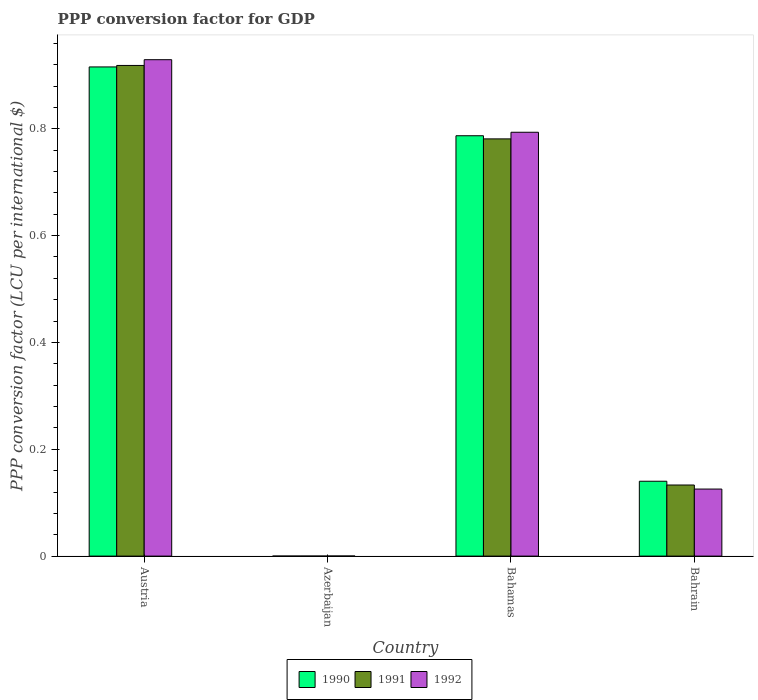How many different coloured bars are there?
Give a very brief answer. 3. How many bars are there on the 3rd tick from the left?
Offer a terse response. 3. What is the label of the 2nd group of bars from the left?
Keep it short and to the point. Azerbaijan. In how many cases, is the number of bars for a given country not equal to the number of legend labels?
Offer a terse response. 0. What is the PPP conversion factor for GDP in 1991 in Azerbaijan?
Give a very brief answer. 1.32217766768327e-5. Across all countries, what is the maximum PPP conversion factor for GDP in 1992?
Ensure brevity in your answer.  0.93. Across all countries, what is the minimum PPP conversion factor for GDP in 1990?
Offer a very short reply. 7.443149847604138e-6. In which country was the PPP conversion factor for GDP in 1991 maximum?
Offer a very short reply. Austria. In which country was the PPP conversion factor for GDP in 1990 minimum?
Make the answer very short. Azerbaijan. What is the total PPP conversion factor for GDP in 1992 in the graph?
Your response must be concise. 1.85. What is the difference between the PPP conversion factor for GDP in 1992 in Austria and that in Bahrain?
Ensure brevity in your answer.  0.8. What is the difference between the PPP conversion factor for GDP in 1992 in Azerbaijan and the PPP conversion factor for GDP in 1990 in Austria?
Make the answer very short. -0.92. What is the average PPP conversion factor for GDP in 1990 per country?
Keep it short and to the point. 0.46. What is the difference between the PPP conversion factor for GDP of/in 1992 and PPP conversion factor for GDP of/in 1990 in Austria?
Provide a succinct answer. 0.01. In how many countries, is the PPP conversion factor for GDP in 1991 greater than 0.08 LCU?
Your response must be concise. 3. What is the ratio of the PPP conversion factor for GDP in 1992 in Bahamas to that in Bahrain?
Your answer should be very brief. 6.32. Is the PPP conversion factor for GDP in 1991 in Austria less than that in Bahrain?
Your answer should be very brief. No. What is the difference between the highest and the second highest PPP conversion factor for GDP in 1990?
Your response must be concise. 0.13. What is the difference between the highest and the lowest PPP conversion factor for GDP in 1991?
Give a very brief answer. 0.92. Is the sum of the PPP conversion factor for GDP in 1991 in Austria and Bahrain greater than the maximum PPP conversion factor for GDP in 1992 across all countries?
Make the answer very short. Yes. Are all the bars in the graph horizontal?
Your answer should be compact. No. Are the values on the major ticks of Y-axis written in scientific E-notation?
Offer a very short reply. No. Does the graph contain any zero values?
Provide a short and direct response. No. Does the graph contain grids?
Ensure brevity in your answer.  No. How many legend labels are there?
Keep it short and to the point. 3. How are the legend labels stacked?
Your answer should be compact. Horizontal. What is the title of the graph?
Make the answer very short. PPP conversion factor for GDP. Does "2010" appear as one of the legend labels in the graph?
Provide a short and direct response. No. What is the label or title of the X-axis?
Make the answer very short. Country. What is the label or title of the Y-axis?
Give a very brief answer. PPP conversion factor (LCU per international $). What is the PPP conversion factor (LCU per international $) in 1990 in Austria?
Make the answer very short. 0.92. What is the PPP conversion factor (LCU per international $) in 1991 in Austria?
Provide a short and direct response. 0.92. What is the PPP conversion factor (LCU per international $) of 1992 in Austria?
Your answer should be very brief. 0.93. What is the PPP conversion factor (LCU per international $) of 1990 in Azerbaijan?
Provide a succinct answer. 7.443149847604138e-6. What is the PPP conversion factor (LCU per international $) of 1991 in Azerbaijan?
Your response must be concise. 1.32217766768327e-5. What is the PPP conversion factor (LCU per international $) in 1992 in Azerbaijan?
Ensure brevity in your answer.  0. What is the PPP conversion factor (LCU per international $) of 1990 in Bahamas?
Offer a very short reply. 0.79. What is the PPP conversion factor (LCU per international $) in 1991 in Bahamas?
Your answer should be very brief. 0.78. What is the PPP conversion factor (LCU per international $) of 1992 in Bahamas?
Ensure brevity in your answer.  0.79. What is the PPP conversion factor (LCU per international $) of 1990 in Bahrain?
Offer a very short reply. 0.14. What is the PPP conversion factor (LCU per international $) of 1991 in Bahrain?
Offer a very short reply. 0.13. What is the PPP conversion factor (LCU per international $) in 1992 in Bahrain?
Provide a succinct answer. 0.13. Across all countries, what is the maximum PPP conversion factor (LCU per international $) of 1990?
Your response must be concise. 0.92. Across all countries, what is the maximum PPP conversion factor (LCU per international $) in 1991?
Provide a succinct answer. 0.92. Across all countries, what is the maximum PPP conversion factor (LCU per international $) of 1992?
Ensure brevity in your answer.  0.93. Across all countries, what is the minimum PPP conversion factor (LCU per international $) in 1990?
Make the answer very short. 7.443149847604138e-6. Across all countries, what is the minimum PPP conversion factor (LCU per international $) in 1991?
Your answer should be compact. 1.32217766768327e-5. Across all countries, what is the minimum PPP conversion factor (LCU per international $) in 1992?
Ensure brevity in your answer.  0. What is the total PPP conversion factor (LCU per international $) of 1990 in the graph?
Offer a terse response. 1.84. What is the total PPP conversion factor (LCU per international $) of 1991 in the graph?
Give a very brief answer. 1.83. What is the total PPP conversion factor (LCU per international $) of 1992 in the graph?
Provide a succinct answer. 1.85. What is the difference between the PPP conversion factor (LCU per international $) in 1990 in Austria and that in Azerbaijan?
Keep it short and to the point. 0.92. What is the difference between the PPP conversion factor (LCU per international $) of 1991 in Austria and that in Azerbaijan?
Your answer should be very brief. 0.92. What is the difference between the PPP conversion factor (LCU per international $) of 1992 in Austria and that in Azerbaijan?
Offer a terse response. 0.93. What is the difference between the PPP conversion factor (LCU per international $) in 1990 in Austria and that in Bahamas?
Your answer should be compact. 0.13. What is the difference between the PPP conversion factor (LCU per international $) in 1991 in Austria and that in Bahamas?
Offer a very short reply. 0.14. What is the difference between the PPP conversion factor (LCU per international $) of 1992 in Austria and that in Bahamas?
Your answer should be very brief. 0.14. What is the difference between the PPP conversion factor (LCU per international $) in 1990 in Austria and that in Bahrain?
Make the answer very short. 0.78. What is the difference between the PPP conversion factor (LCU per international $) in 1991 in Austria and that in Bahrain?
Offer a very short reply. 0.79. What is the difference between the PPP conversion factor (LCU per international $) of 1992 in Austria and that in Bahrain?
Your answer should be very brief. 0.8. What is the difference between the PPP conversion factor (LCU per international $) of 1990 in Azerbaijan and that in Bahamas?
Ensure brevity in your answer.  -0.79. What is the difference between the PPP conversion factor (LCU per international $) of 1991 in Azerbaijan and that in Bahamas?
Provide a succinct answer. -0.78. What is the difference between the PPP conversion factor (LCU per international $) of 1992 in Azerbaijan and that in Bahamas?
Your answer should be compact. -0.79. What is the difference between the PPP conversion factor (LCU per international $) of 1990 in Azerbaijan and that in Bahrain?
Your answer should be compact. -0.14. What is the difference between the PPP conversion factor (LCU per international $) in 1991 in Azerbaijan and that in Bahrain?
Your answer should be very brief. -0.13. What is the difference between the PPP conversion factor (LCU per international $) of 1992 in Azerbaijan and that in Bahrain?
Offer a terse response. -0.13. What is the difference between the PPP conversion factor (LCU per international $) of 1990 in Bahamas and that in Bahrain?
Provide a short and direct response. 0.65. What is the difference between the PPP conversion factor (LCU per international $) in 1991 in Bahamas and that in Bahrain?
Make the answer very short. 0.65. What is the difference between the PPP conversion factor (LCU per international $) of 1992 in Bahamas and that in Bahrain?
Provide a short and direct response. 0.67. What is the difference between the PPP conversion factor (LCU per international $) of 1990 in Austria and the PPP conversion factor (LCU per international $) of 1991 in Azerbaijan?
Provide a short and direct response. 0.92. What is the difference between the PPP conversion factor (LCU per international $) in 1990 in Austria and the PPP conversion factor (LCU per international $) in 1992 in Azerbaijan?
Your response must be concise. 0.92. What is the difference between the PPP conversion factor (LCU per international $) in 1991 in Austria and the PPP conversion factor (LCU per international $) in 1992 in Azerbaijan?
Your answer should be very brief. 0.92. What is the difference between the PPP conversion factor (LCU per international $) of 1990 in Austria and the PPP conversion factor (LCU per international $) of 1991 in Bahamas?
Keep it short and to the point. 0.13. What is the difference between the PPP conversion factor (LCU per international $) of 1990 in Austria and the PPP conversion factor (LCU per international $) of 1992 in Bahamas?
Make the answer very short. 0.12. What is the difference between the PPP conversion factor (LCU per international $) of 1991 in Austria and the PPP conversion factor (LCU per international $) of 1992 in Bahamas?
Give a very brief answer. 0.13. What is the difference between the PPP conversion factor (LCU per international $) of 1990 in Austria and the PPP conversion factor (LCU per international $) of 1991 in Bahrain?
Make the answer very short. 0.78. What is the difference between the PPP conversion factor (LCU per international $) of 1990 in Austria and the PPP conversion factor (LCU per international $) of 1992 in Bahrain?
Give a very brief answer. 0.79. What is the difference between the PPP conversion factor (LCU per international $) in 1991 in Austria and the PPP conversion factor (LCU per international $) in 1992 in Bahrain?
Provide a short and direct response. 0.79. What is the difference between the PPP conversion factor (LCU per international $) of 1990 in Azerbaijan and the PPP conversion factor (LCU per international $) of 1991 in Bahamas?
Provide a succinct answer. -0.78. What is the difference between the PPP conversion factor (LCU per international $) of 1990 in Azerbaijan and the PPP conversion factor (LCU per international $) of 1992 in Bahamas?
Provide a short and direct response. -0.79. What is the difference between the PPP conversion factor (LCU per international $) of 1991 in Azerbaijan and the PPP conversion factor (LCU per international $) of 1992 in Bahamas?
Ensure brevity in your answer.  -0.79. What is the difference between the PPP conversion factor (LCU per international $) in 1990 in Azerbaijan and the PPP conversion factor (LCU per international $) in 1991 in Bahrain?
Offer a very short reply. -0.13. What is the difference between the PPP conversion factor (LCU per international $) in 1990 in Azerbaijan and the PPP conversion factor (LCU per international $) in 1992 in Bahrain?
Provide a short and direct response. -0.13. What is the difference between the PPP conversion factor (LCU per international $) in 1991 in Azerbaijan and the PPP conversion factor (LCU per international $) in 1992 in Bahrain?
Keep it short and to the point. -0.13. What is the difference between the PPP conversion factor (LCU per international $) in 1990 in Bahamas and the PPP conversion factor (LCU per international $) in 1991 in Bahrain?
Offer a very short reply. 0.65. What is the difference between the PPP conversion factor (LCU per international $) in 1990 in Bahamas and the PPP conversion factor (LCU per international $) in 1992 in Bahrain?
Keep it short and to the point. 0.66. What is the difference between the PPP conversion factor (LCU per international $) in 1991 in Bahamas and the PPP conversion factor (LCU per international $) in 1992 in Bahrain?
Keep it short and to the point. 0.66. What is the average PPP conversion factor (LCU per international $) of 1990 per country?
Your answer should be compact. 0.46. What is the average PPP conversion factor (LCU per international $) of 1991 per country?
Keep it short and to the point. 0.46. What is the average PPP conversion factor (LCU per international $) in 1992 per country?
Keep it short and to the point. 0.46. What is the difference between the PPP conversion factor (LCU per international $) in 1990 and PPP conversion factor (LCU per international $) in 1991 in Austria?
Provide a short and direct response. -0. What is the difference between the PPP conversion factor (LCU per international $) of 1990 and PPP conversion factor (LCU per international $) of 1992 in Austria?
Provide a short and direct response. -0.01. What is the difference between the PPP conversion factor (LCU per international $) in 1991 and PPP conversion factor (LCU per international $) in 1992 in Austria?
Your answer should be compact. -0.01. What is the difference between the PPP conversion factor (LCU per international $) of 1990 and PPP conversion factor (LCU per international $) of 1992 in Azerbaijan?
Offer a terse response. -0. What is the difference between the PPP conversion factor (LCU per international $) in 1991 and PPP conversion factor (LCU per international $) in 1992 in Azerbaijan?
Offer a very short reply. -0. What is the difference between the PPP conversion factor (LCU per international $) in 1990 and PPP conversion factor (LCU per international $) in 1991 in Bahamas?
Offer a very short reply. 0.01. What is the difference between the PPP conversion factor (LCU per international $) of 1990 and PPP conversion factor (LCU per international $) of 1992 in Bahamas?
Keep it short and to the point. -0.01. What is the difference between the PPP conversion factor (LCU per international $) of 1991 and PPP conversion factor (LCU per international $) of 1992 in Bahamas?
Offer a terse response. -0.01. What is the difference between the PPP conversion factor (LCU per international $) in 1990 and PPP conversion factor (LCU per international $) in 1991 in Bahrain?
Keep it short and to the point. 0.01. What is the difference between the PPP conversion factor (LCU per international $) of 1990 and PPP conversion factor (LCU per international $) of 1992 in Bahrain?
Offer a terse response. 0.01. What is the difference between the PPP conversion factor (LCU per international $) in 1991 and PPP conversion factor (LCU per international $) in 1992 in Bahrain?
Give a very brief answer. 0.01. What is the ratio of the PPP conversion factor (LCU per international $) of 1990 in Austria to that in Azerbaijan?
Offer a very short reply. 1.23e+05. What is the ratio of the PPP conversion factor (LCU per international $) in 1991 in Austria to that in Azerbaijan?
Your response must be concise. 6.95e+04. What is the ratio of the PPP conversion factor (LCU per international $) of 1992 in Austria to that in Azerbaijan?
Your answer should be very brief. 6169.56. What is the ratio of the PPP conversion factor (LCU per international $) of 1990 in Austria to that in Bahamas?
Give a very brief answer. 1.16. What is the ratio of the PPP conversion factor (LCU per international $) in 1991 in Austria to that in Bahamas?
Your answer should be compact. 1.18. What is the ratio of the PPP conversion factor (LCU per international $) in 1992 in Austria to that in Bahamas?
Offer a terse response. 1.17. What is the ratio of the PPP conversion factor (LCU per international $) in 1990 in Austria to that in Bahrain?
Provide a short and direct response. 6.53. What is the ratio of the PPP conversion factor (LCU per international $) of 1991 in Austria to that in Bahrain?
Ensure brevity in your answer.  6.9. What is the ratio of the PPP conversion factor (LCU per international $) in 1992 in Austria to that in Bahrain?
Ensure brevity in your answer.  7.4. What is the ratio of the PPP conversion factor (LCU per international $) in 1990 in Azerbaijan to that in Bahamas?
Offer a very short reply. 0. What is the ratio of the PPP conversion factor (LCU per international $) in 1991 in Azerbaijan to that in Bahamas?
Provide a succinct answer. 0. What is the ratio of the PPP conversion factor (LCU per international $) of 1992 in Azerbaijan to that in Bahamas?
Ensure brevity in your answer.  0. What is the ratio of the PPP conversion factor (LCU per international $) in 1991 in Azerbaijan to that in Bahrain?
Offer a terse response. 0. What is the ratio of the PPP conversion factor (LCU per international $) of 1992 in Azerbaijan to that in Bahrain?
Your answer should be very brief. 0. What is the ratio of the PPP conversion factor (LCU per international $) in 1990 in Bahamas to that in Bahrain?
Provide a succinct answer. 5.62. What is the ratio of the PPP conversion factor (LCU per international $) of 1991 in Bahamas to that in Bahrain?
Keep it short and to the point. 5.87. What is the ratio of the PPP conversion factor (LCU per international $) of 1992 in Bahamas to that in Bahrain?
Give a very brief answer. 6.32. What is the difference between the highest and the second highest PPP conversion factor (LCU per international $) in 1990?
Your answer should be compact. 0.13. What is the difference between the highest and the second highest PPP conversion factor (LCU per international $) in 1991?
Give a very brief answer. 0.14. What is the difference between the highest and the second highest PPP conversion factor (LCU per international $) of 1992?
Your answer should be compact. 0.14. What is the difference between the highest and the lowest PPP conversion factor (LCU per international $) of 1990?
Provide a short and direct response. 0.92. What is the difference between the highest and the lowest PPP conversion factor (LCU per international $) in 1991?
Provide a succinct answer. 0.92. What is the difference between the highest and the lowest PPP conversion factor (LCU per international $) of 1992?
Your answer should be very brief. 0.93. 